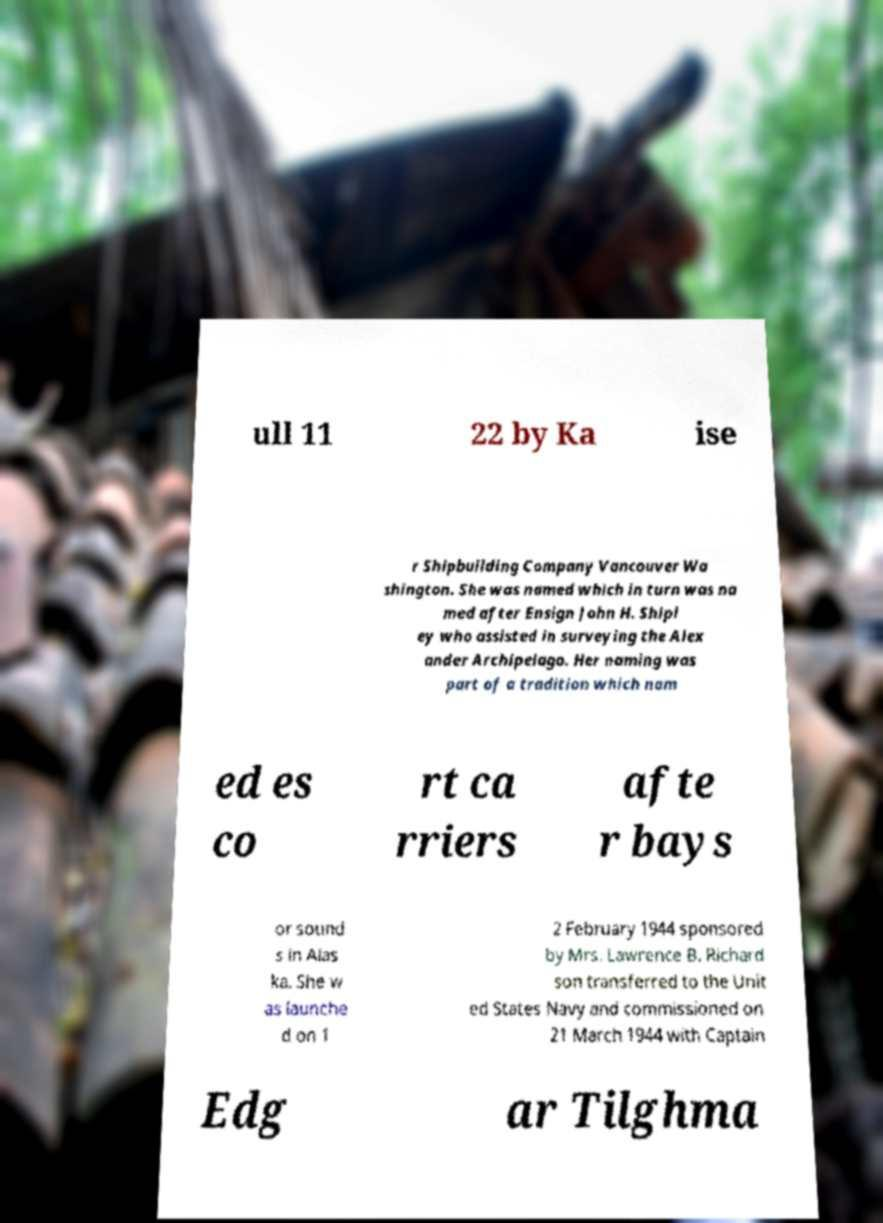Please identify and transcribe the text found in this image. ull 11 22 by Ka ise r Shipbuilding Company Vancouver Wa shington. She was named which in turn was na med after Ensign John H. Shipl ey who assisted in surveying the Alex ander Archipelago. Her naming was part of a tradition which nam ed es co rt ca rriers afte r bays or sound s in Alas ka. She w as launche d on 1 2 February 1944 sponsored by Mrs. Lawrence B. Richard son transferred to the Unit ed States Navy and commissioned on 21 March 1944 with Captain Edg ar Tilghma 